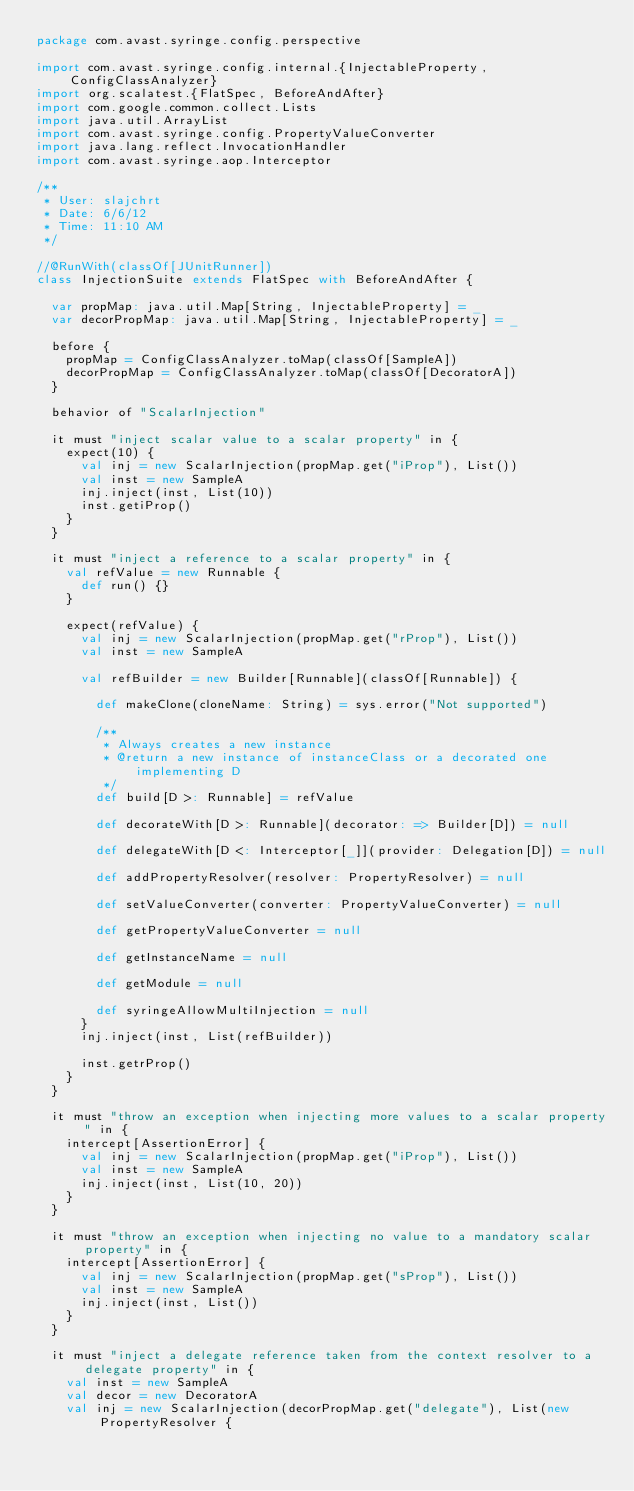Convert code to text. <code><loc_0><loc_0><loc_500><loc_500><_Scala_>package com.avast.syringe.config.perspective

import com.avast.syringe.config.internal.{InjectableProperty, ConfigClassAnalyzer}
import org.scalatest.{FlatSpec, BeforeAndAfter}
import com.google.common.collect.Lists
import java.util.ArrayList
import com.avast.syringe.config.PropertyValueConverter
import java.lang.reflect.InvocationHandler
import com.avast.syringe.aop.Interceptor

/**
 * User: slajchrt
 * Date: 6/6/12
 * Time: 11:10 AM
 */

//@RunWith(classOf[JUnitRunner])
class InjectionSuite extends FlatSpec with BeforeAndAfter {

  var propMap: java.util.Map[String, InjectableProperty] = _
  var decorPropMap: java.util.Map[String, InjectableProperty] = _

  before {
    propMap = ConfigClassAnalyzer.toMap(classOf[SampleA])
    decorPropMap = ConfigClassAnalyzer.toMap(classOf[DecoratorA])
  }

  behavior of "ScalarInjection"

  it must "inject scalar value to a scalar property" in {
    expect(10) {
      val inj = new ScalarInjection(propMap.get("iProp"), List())
      val inst = new SampleA
      inj.inject(inst, List(10))
      inst.getiProp()
    }
  }

  it must "inject a reference to a scalar property" in {
    val refValue = new Runnable {
      def run() {}
    }

    expect(refValue) {
      val inj = new ScalarInjection(propMap.get("rProp"), List())
      val inst = new SampleA

      val refBuilder = new Builder[Runnable](classOf[Runnable]) {

        def makeClone(cloneName: String) = sys.error("Not supported")

        /**
         * Always creates a new instance
         * @return a new instance of instanceClass or a decorated one implementing D
         */
        def build[D >: Runnable] = refValue

        def decorateWith[D >: Runnable](decorator: => Builder[D]) = null

        def delegateWith[D <: Interceptor[_]](provider: Delegation[D]) = null

        def addPropertyResolver(resolver: PropertyResolver) = null

        def setValueConverter(converter: PropertyValueConverter) = null

        def getPropertyValueConverter = null

        def getInstanceName = null

        def getModule = null

        def syringeAllowMultiInjection = null
      }
      inj.inject(inst, List(refBuilder))

      inst.getrProp()
    }
  }

  it must "throw an exception when injecting more values to a scalar property" in {
    intercept[AssertionError] {
      val inj = new ScalarInjection(propMap.get("iProp"), List())
      val inst = new SampleA
      inj.inject(inst, List(10, 20))
    }
  }

  it must "throw an exception when injecting no value to a mandatory scalar property" in {
    intercept[AssertionError] {
      val inj = new ScalarInjection(propMap.get("sProp"), List())
      val inst = new SampleA
      inj.inject(inst, List())
    }
  }

  it must "inject a delegate reference taken from the context resolver to a delegate property" in {
    val inst = new SampleA
    val decor = new DecoratorA
    val inj = new ScalarInjection(decorPropMap.get("delegate"), List(new PropertyResolver {</code> 